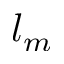<formula> <loc_0><loc_0><loc_500><loc_500>l _ { m }</formula> 